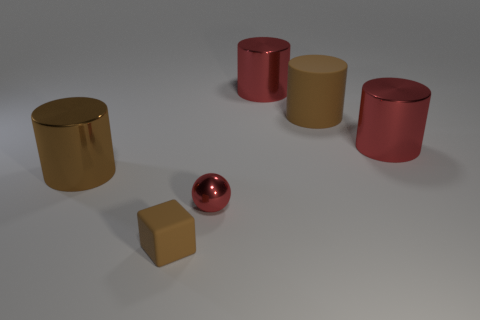How many other things are the same shape as the small brown matte object?
Provide a succinct answer. 0. Are there more large metallic cylinders that are in front of the brown matte cube than rubber things that are behind the metallic sphere?
Provide a short and direct response. No. There is a rubber thing behind the small metal sphere; is its size the same as the brown metallic cylinder behind the small block?
Provide a short and direct response. Yes. The small brown rubber object is what shape?
Keep it short and to the point. Cube. What size is the matte thing that is the same color as the large rubber cylinder?
Provide a succinct answer. Small. What color is the large object that is the same material as the tiny cube?
Provide a succinct answer. Brown. Does the brown cube have the same material as the brown object that is behind the brown shiny cylinder?
Keep it short and to the point. Yes. What color is the small shiny ball?
Provide a short and direct response. Red. The brown object that is the same material as the small red object is what size?
Provide a short and direct response. Large. There is a brown thing that is in front of the big shiny cylinder left of the small brown block; what number of big brown metal objects are behind it?
Keep it short and to the point. 1. 